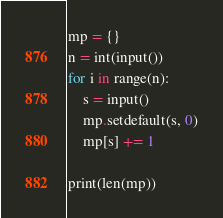Convert code to text. <code><loc_0><loc_0><loc_500><loc_500><_Python_>mp = {}
n = int(input())
for i in range(n):
    s = input()
    mp.setdefault(s, 0)
    mp[s] += 1

print(len(mp))</code> 